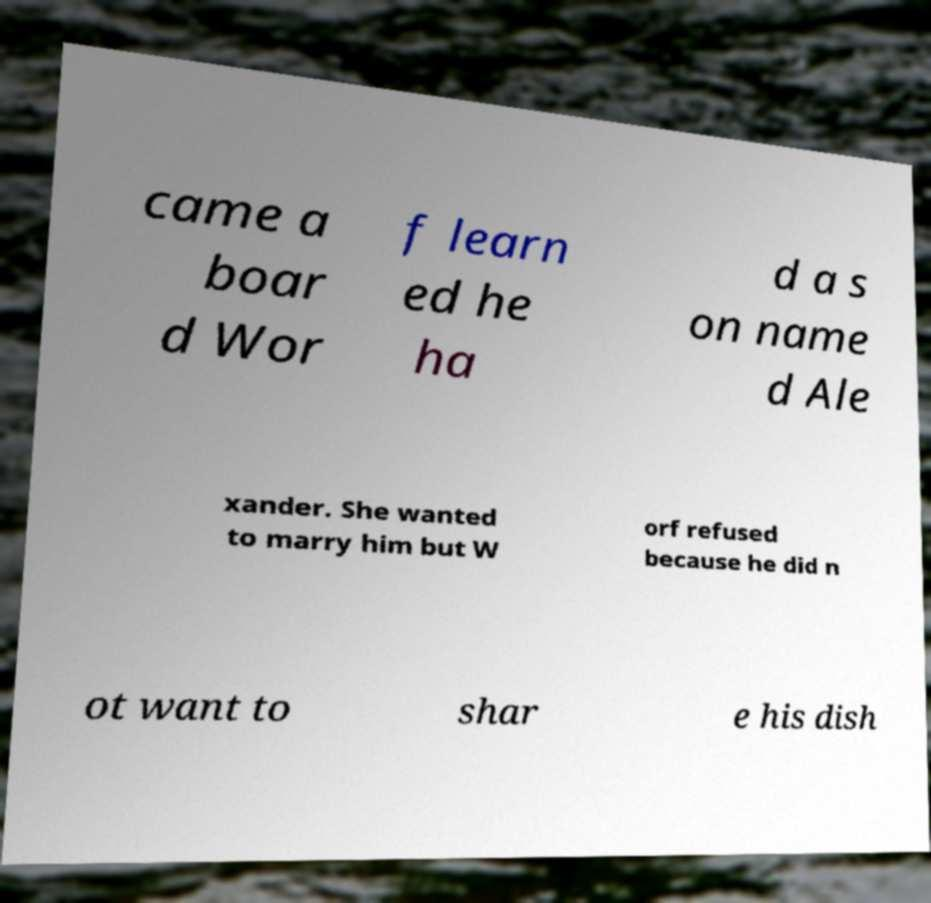Can you accurately transcribe the text from the provided image for me? came a boar d Wor f learn ed he ha d a s on name d Ale xander. She wanted to marry him but W orf refused because he did n ot want to shar e his dish 